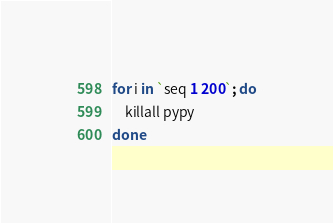Convert code to text. <code><loc_0><loc_0><loc_500><loc_500><_Bash_>
for i in `seq 1 200`; do
    killall pypy
done
</code> 